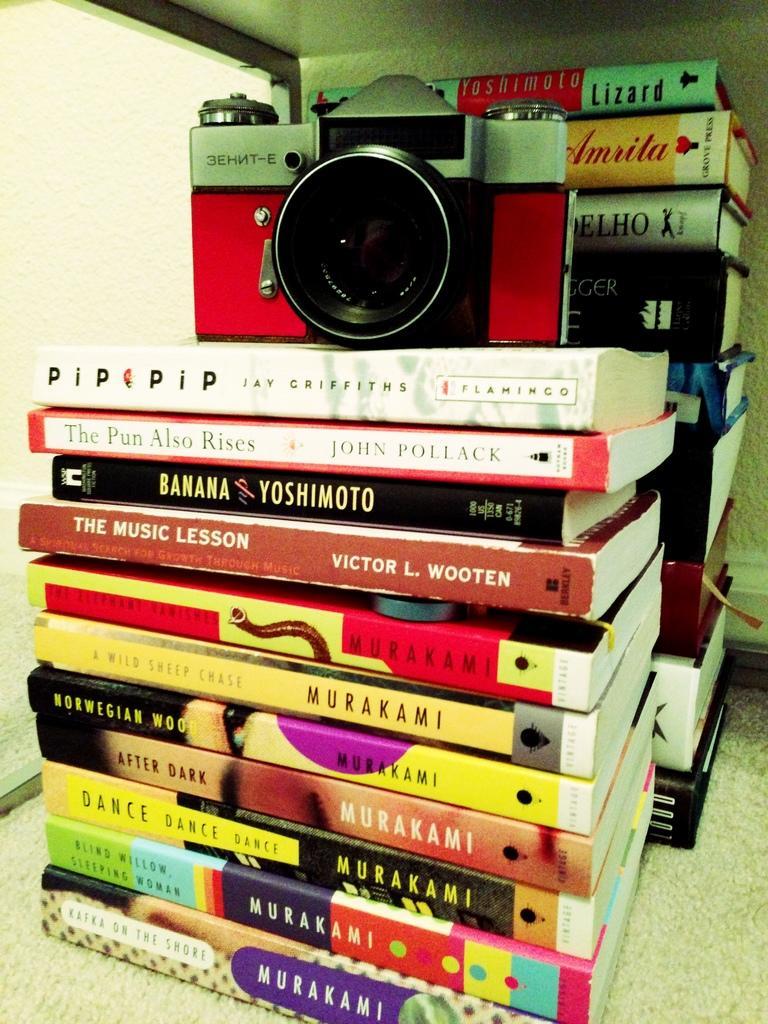Describe this image in one or two sentences. In the center of the image we can see books and a camera. 